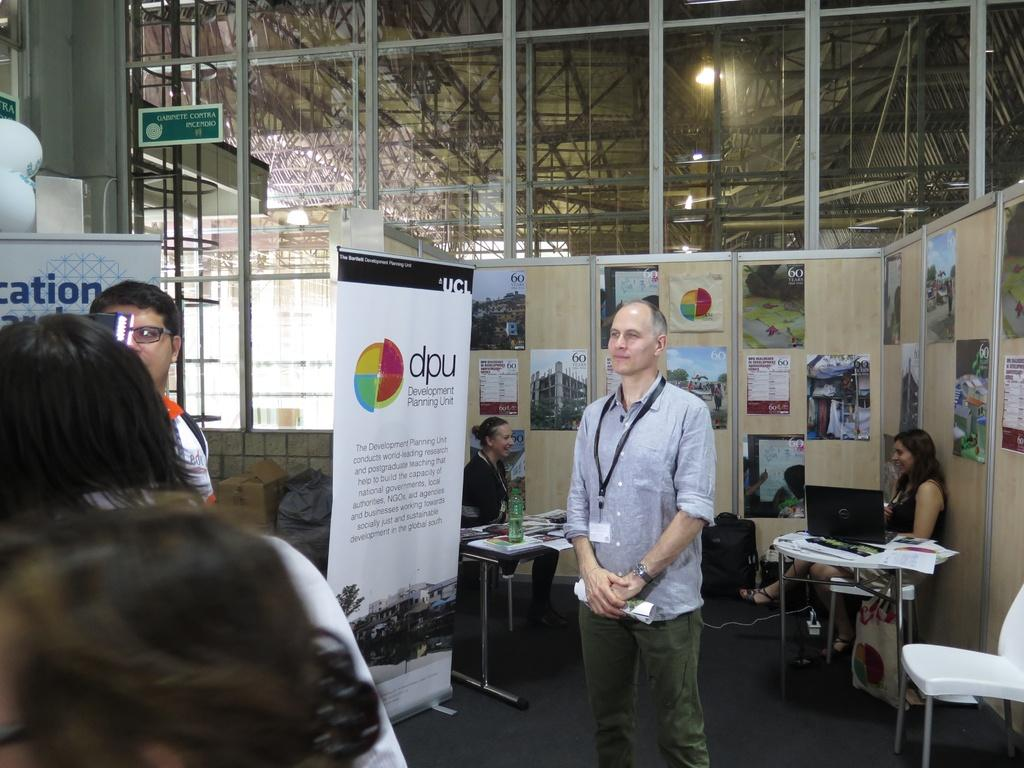How many people are in the room in the image? There are many people in the room in the image. What furniture is present in the room? The room contains a table and chairs. What electronic devices are in the room? The room contains laptops. What decorations are in the room? The room contains posters. What items are on the table in the image? The table contains papers and books. What type of food is being served on the table in the image? There is no food present on the table in the image; it contains papers and books. Can you see a mitten in the image? There is no mitten present in the image. 